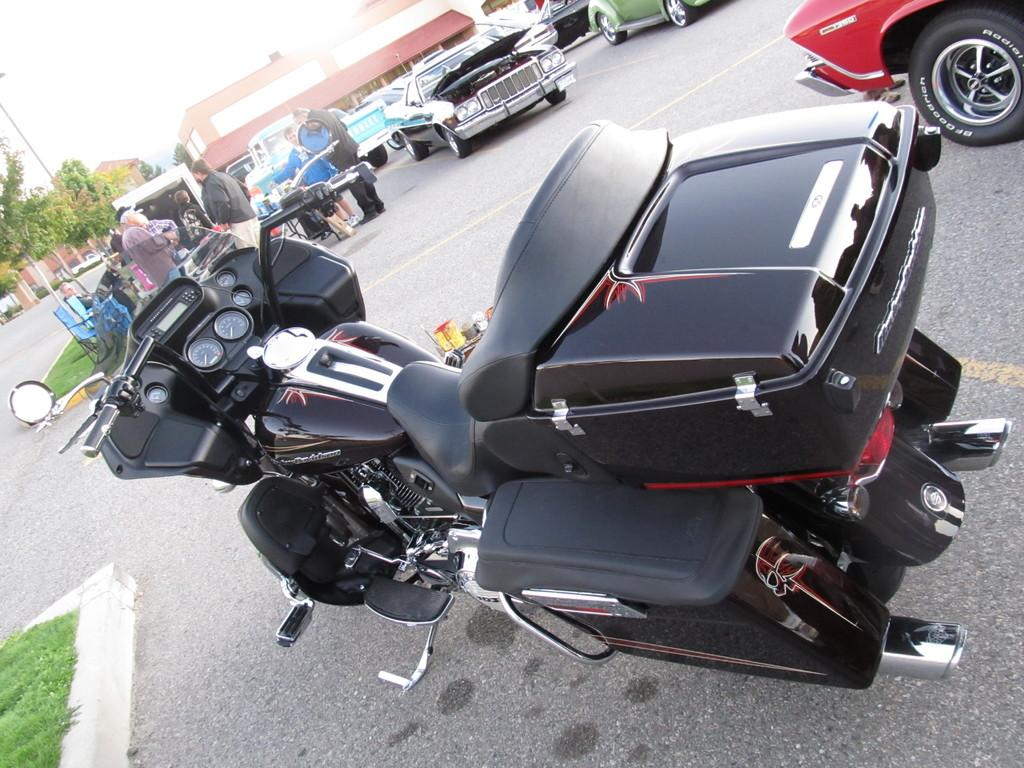What type of bike is in the image? There is a black color bike in the image. Where is the bike located? The bike is parked on the road. What can be seen in the background of the image? Cars, people, trees, a pole, a building, and the sky are visible in the background of the image. What date is marked on the calendar in the image? There is no calendar present in the image. Can you hear the horn of the bike in the image? There is no sound in the image, so it is not possible to hear any horn. 